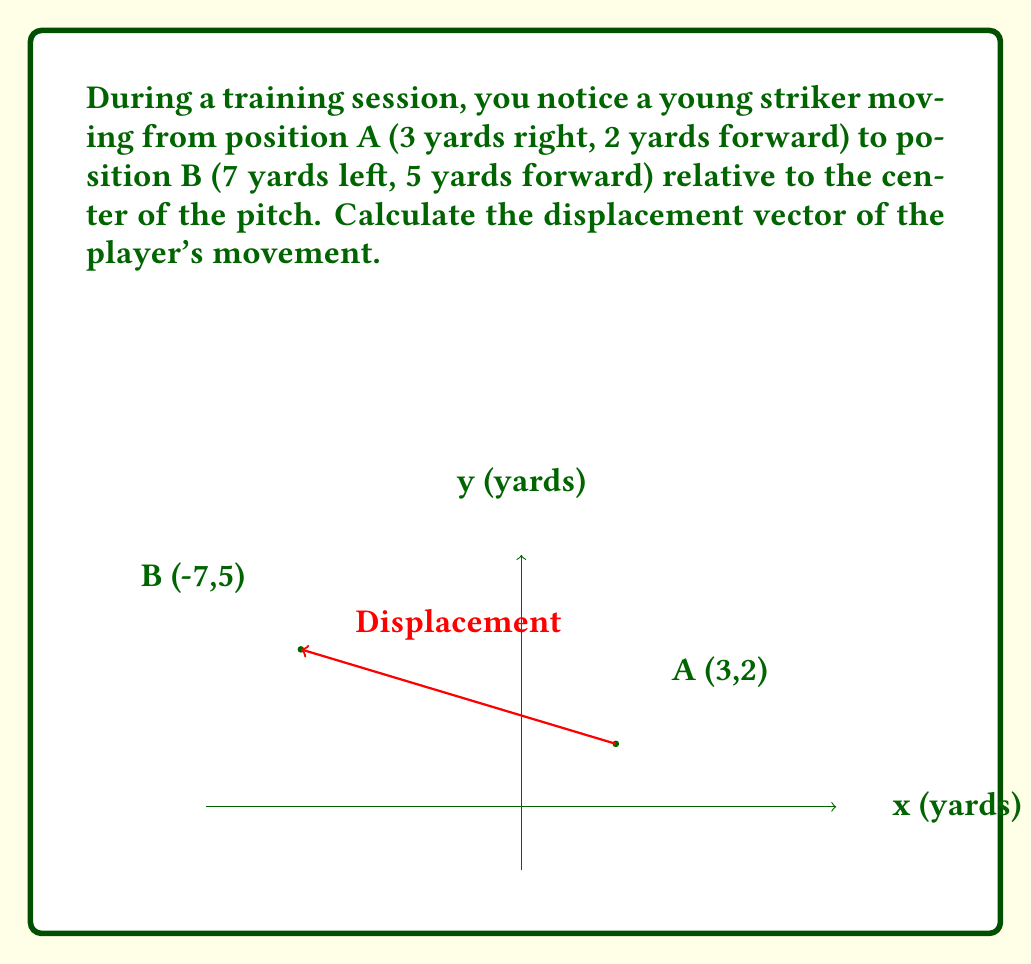Show me your answer to this math problem. To find the displacement vector, we need to subtract the initial position vector from the final position vector.

1) Initial position (A): $\vec{a} = (3, 2)$
2) Final position (B): $\vec{b} = (-7, 5)$

3) Displacement vector $\vec{d} = \vec{b} - \vec{a}$

4) Calculating the components:
   x-component: $d_x = -7 - 3 = -10$ yards
   y-component: $d_y = 5 - 2 = 3$ yards

5) Therefore, the displacement vector is:
   $$\vec{d} = (-10, 3)$$

This means the player has moved 10 yards to the left and 3 yards forward.

6) The magnitude (length) of the displacement vector can be calculated using the Pythagorean theorem:
   $$|\vec{d}| = \sqrt{(-10)^2 + 3^2} = \sqrt{100 + 9} = \sqrt{109} \approx 10.44$$ yards

7) The direction can be found using the arctangent function:
   $$\theta = \tan^{-1}\left(\frac{3}{-10}\right) \approx -16.70°$$
   
   This angle is measured from the negative x-axis (left). To express it from the positive x-axis, we add 180°:
   $$180° + (-16.70°) = 163.30°$$
Answer: $\vec{d} = (-10, 3)$ yards 